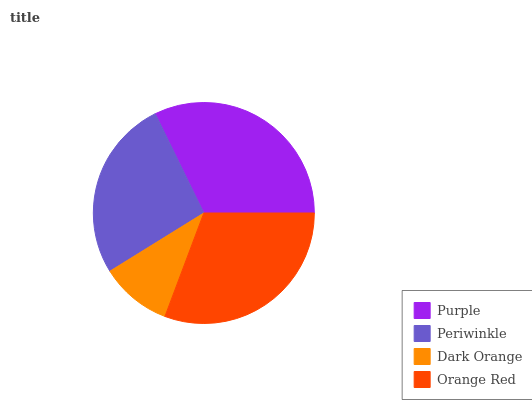Is Dark Orange the minimum?
Answer yes or no. Yes. Is Purple the maximum?
Answer yes or no. Yes. Is Periwinkle the minimum?
Answer yes or no. No. Is Periwinkle the maximum?
Answer yes or no. No. Is Purple greater than Periwinkle?
Answer yes or no. Yes. Is Periwinkle less than Purple?
Answer yes or no. Yes. Is Periwinkle greater than Purple?
Answer yes or no. No. Is Purple less than Periwinkle?
Answer yes or no. No. Is Orange Red the high median?
Answer yes or no. Yes. Is Periwinkle the low median?
Answer yes or no. Yes. Is Purple the high median?
Answer yes or no. No. Is Purple the low median?
Answer yes or no. No. 